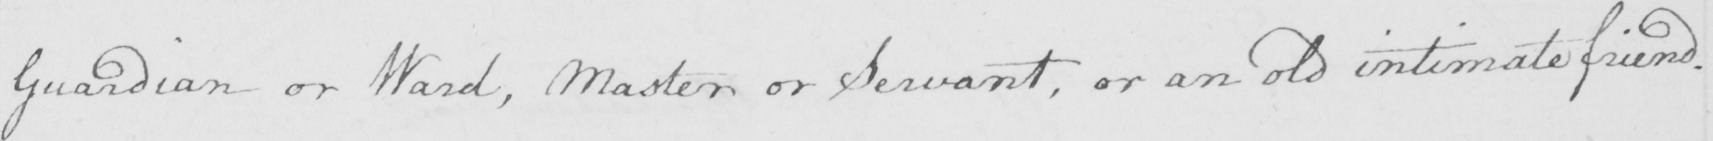Please provide the text content of this handwritten line. Guardian or Ward , Master or Servant , or an old intimate friend . 